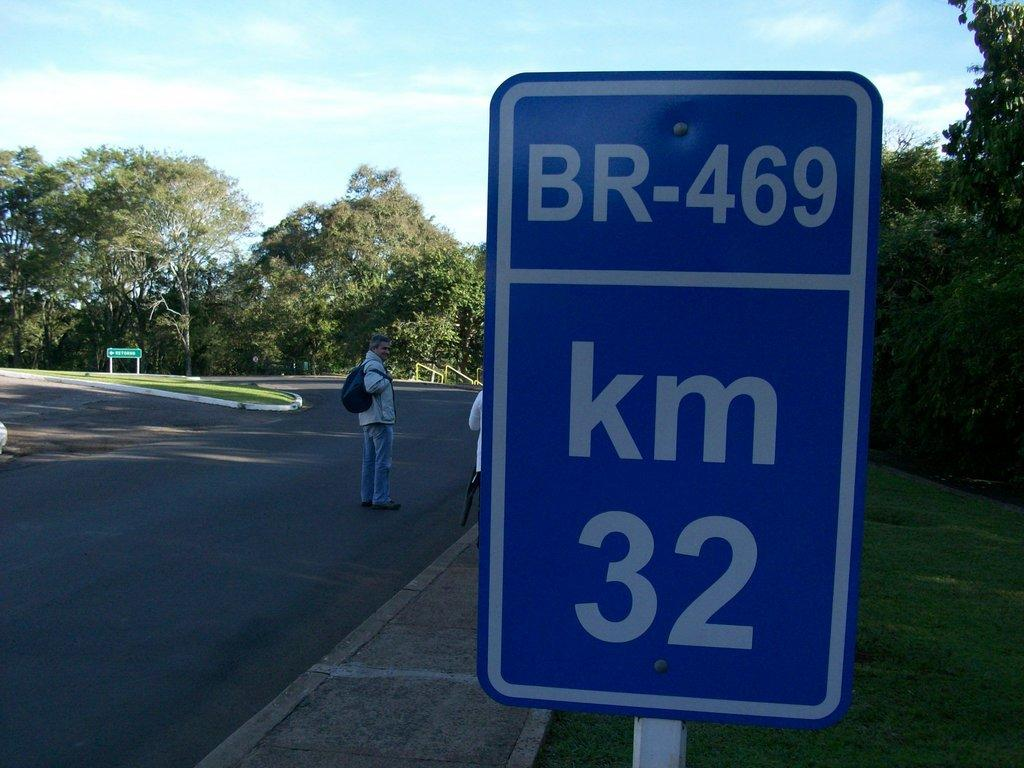Provide a one-sentence caption for the provided image. people standing on the street and a km br 469 street sign. 